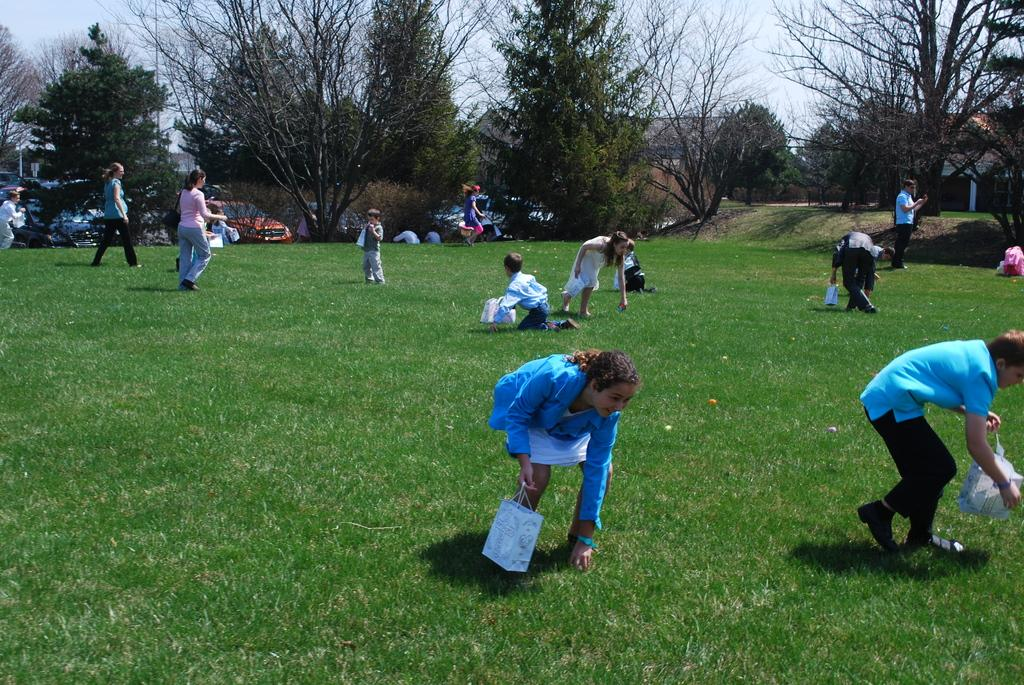How many people are in the image? There are people in the image, but the exact number is not specified. What are the people holding in the image? The people are holding carry bags in the image. What is on the ground in the image? There is grass on the ground in the image. What type of vegetation is present in the image? There are trees in the image. What can be seen behind the trees in the image? There are vehicles and buildings behind the trees in the image. What is visible in the sky in the image? The sky is visible in the image. What type of shop can be seen in the image? There is no shop present in the image. How does the airport affect the people in the image? There is no mention of an airport in the image, so its impact on the people cannot be determined. 